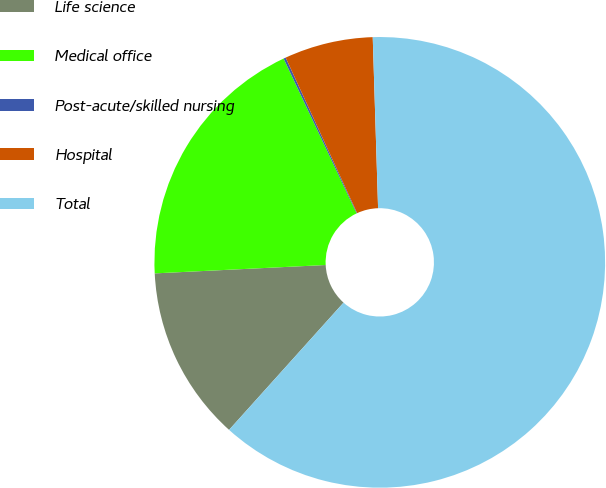Convert chart to OTSL. <chart><loc_0><loc_0><loc_500><loc_500><pie_chart><fcel>Life science<fcel>Medical office<fcel>Post-acute/skilled nursing<fcel>Hospital<fcel>Total<nl><fcel>12.56%<fcel>18.76%<fcel>0.16%<fcel>6.36%<fcel>62.15%<nl></chart> 